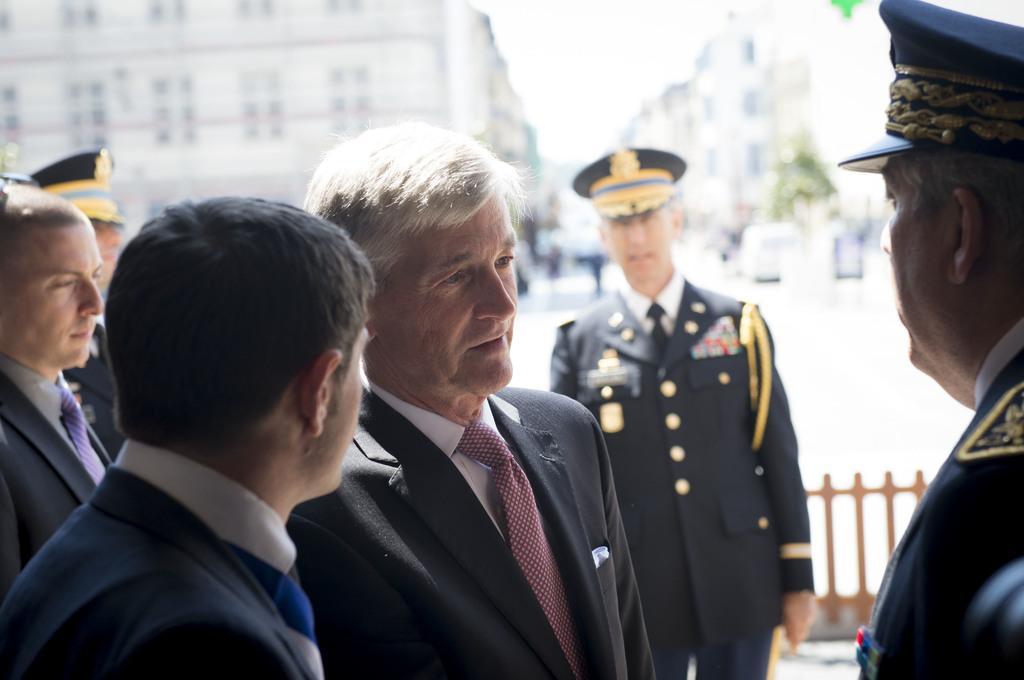How would you summarize this image in a sentence or two? In the given image i can see a people wearing jackets,people wearing caps and in the background i can see the fence. 